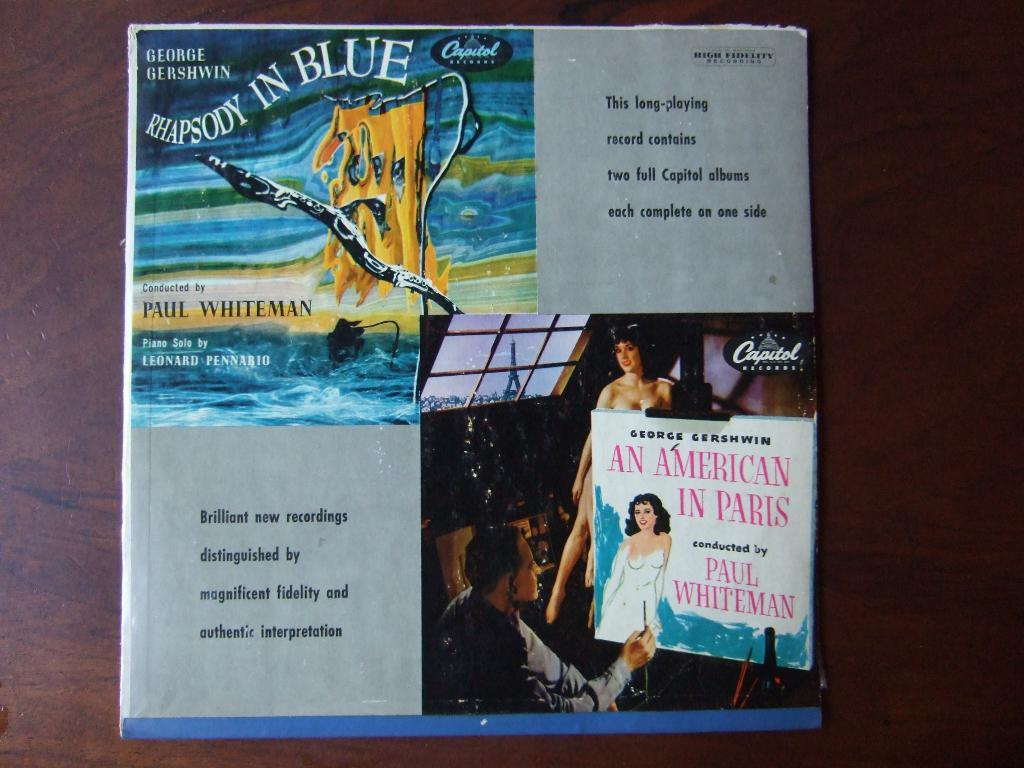<image>
Render a clear and concise summary of the photo. A record cover is titled Rhapsody in Blue. 